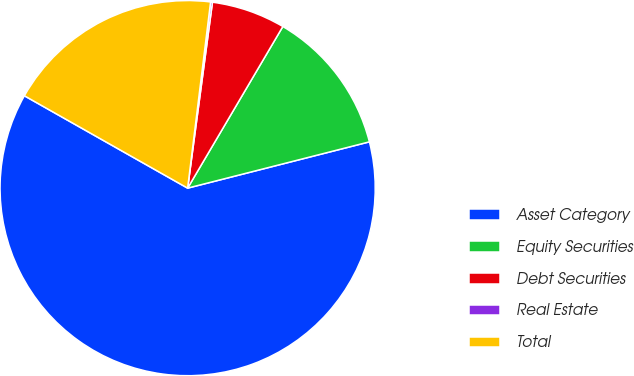<chart> <loc_0><loc_0><loc_500><loc_500><pie_chart><fcel>Asset Category<fcel>Equity Securities<fcel>Debt Securities<fcel>Real Estate<fcel>Total<nl><fcel>62.17%<fcel>12.56%<fcel>6.36%<fcel>0.16%<fcel>18.76%<nl></chart> 